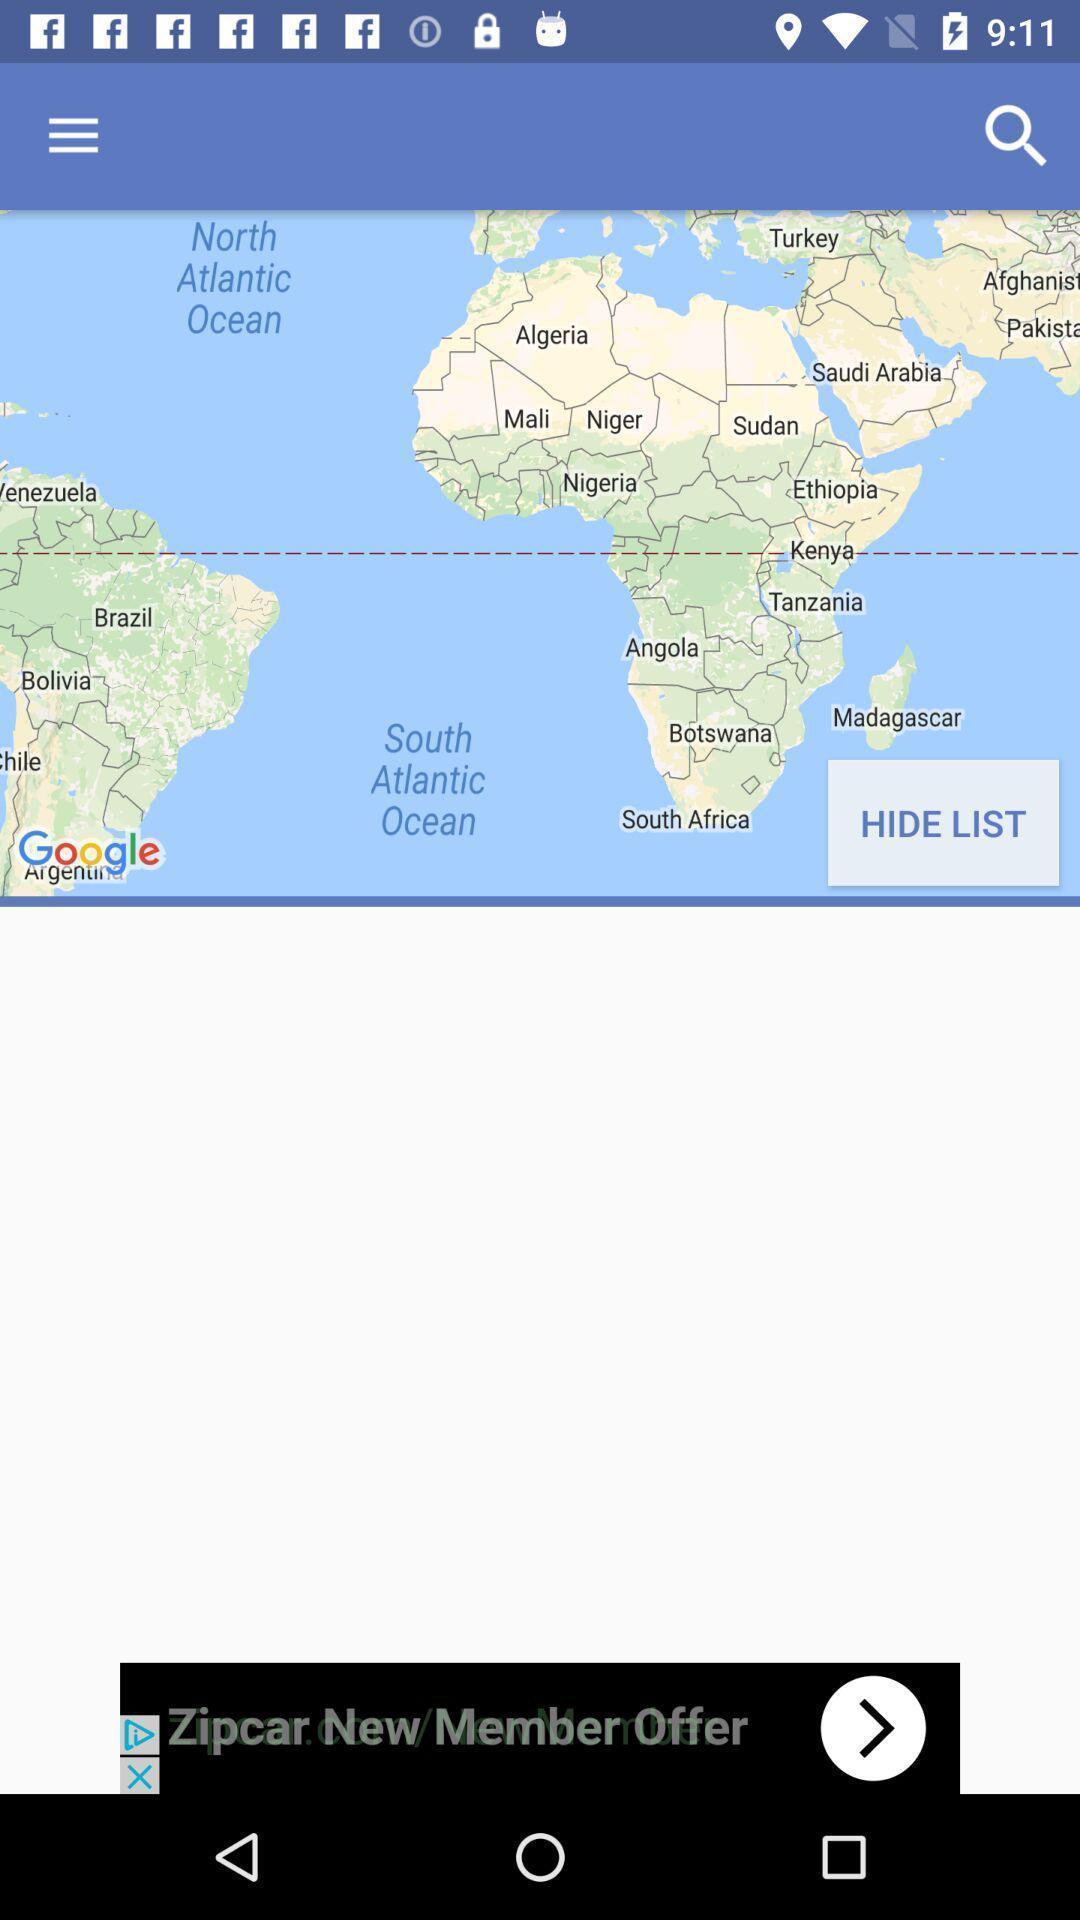Describe the visual elements of this screenshot. Page that displaying a map. 